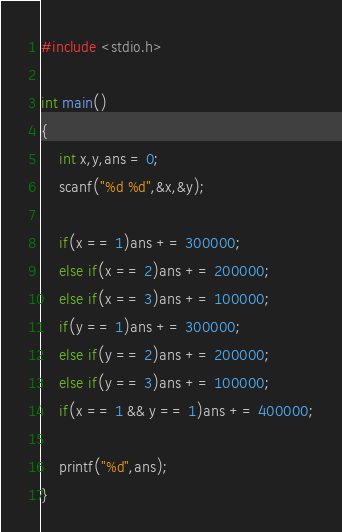<code> <loc_0><loc_0><loc_500><loc_500><_C_>#include <stdio.h>

int main()
{
    int x,y,ans = 0;
    scanf("%d %d",&x,&y);

    if(x == 1)ans += 300000;
    else if(x == 2)ans += 200000;
    else if(x == 3)ans += 100000;
    if(y == 1)ans += 300000;
    else if(y == 2)ans += 200000;
    else if(y == 3)ans += 100000;
    if(x == 1 && y == 1)ans += 400000;

    printf("%d",ans);
}</code> 